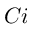<formula> <loc_0><loc_0><loc_500><loc_500>C i</formula> 